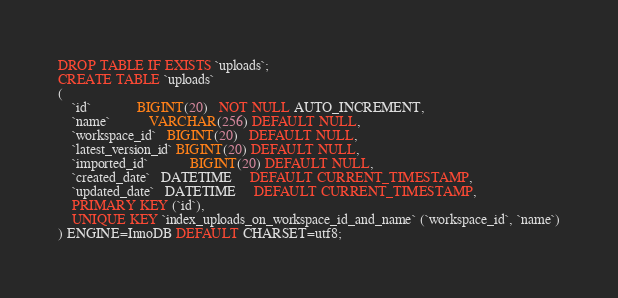Convert code to text. <code><loc_0><loc_0><loc_500><loc_500><_SQL_>DROP TABLE IF EXISTS `uploads`;
CREATE TABLE `uploads`
(
    `id`             BIGINT(20)   NOT NULL AUTO_INCREMENT,
    `name`           VARCHAR(256) DEFAULT NULL,
    `workspace_id`   BIGINT(20)   DEFAULT NULL,
    `latest_version_id` BIGINT(20) DEFAULT NULL,
    `imported_id`            BIGINT(20) DEFAULT NULL,
    `created_date`   DATETIME     DEFAULT CURRENT_TIMESTAMP,
    `updated_date`   DATETIME     DEFAULT CURRENT_TIMESTAMP,
    PRIMARY KEY (`id`),
    UNIQUE KEY `index_uploads_on_workspace_id_and_name` (`workspace_id`, `name`)
) ENGINE=InnoDB DEFAULT CHARSET=utf8;



</code> 